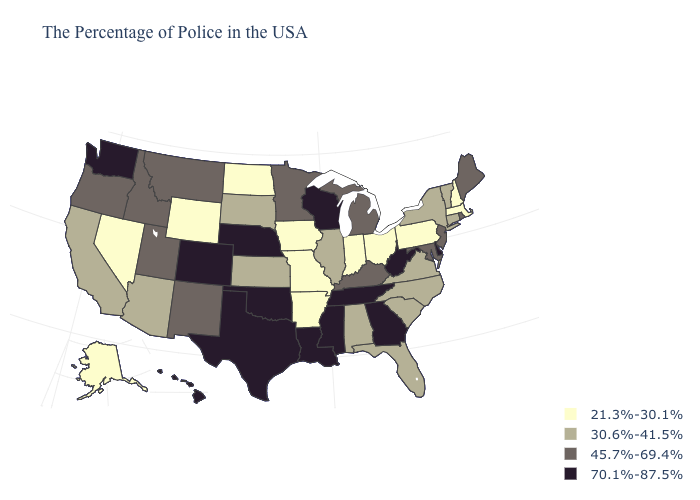Does Ohio have the lowest value in the MidWest?
Keep it brief. Yes. Which states have the lowest value in the USA?
Concise answer only. Massachusetts, New Hampshire, Pennsylvania, Ohio, Indiana, Missouri, Arkansas, Iowa, North Dakota, Wyoming, Nevada, Alaska. What is the highest value in states that border Indiana?
Answer briefly. 45.7%-69.4%. What is the value of Wisconsin?
Concise answer only. 70.1%-87.5%. Which states have the lowest value in the MidWest?
Give a very brief answer. Ohio, Indiana, Missouri, Iowa, North Dakota. What is the value of Kansas?
Concise answer only. 30.6%-41.5%. What is the value of Texas?
Keep it brief. 70.1%-87.5%. What is the value of Montana?
Concise answer only. 45.7%-69.4%. Does Delaware have the same value as Washington?
Be succinct. Yes. What is the lowest value in the West?
Keep it brief. 21.3%-30.1%. Does New Jersey have a lower value than Wisconsin?
Be succinct. Yes. Does Florida have the lowest value in the USA?
Be succinct. No. What is the value of Florida?
Concise answer only. 30.6%-41.5%. Which states have the lowest value in the USA?
Short answer required. Massachusetts, New Hampshire, Pennsylvania, Ohio, Indiana, Missouri, Arkansas, Iowa, North Dakota, Wyoming, Nevada, Alaska. 